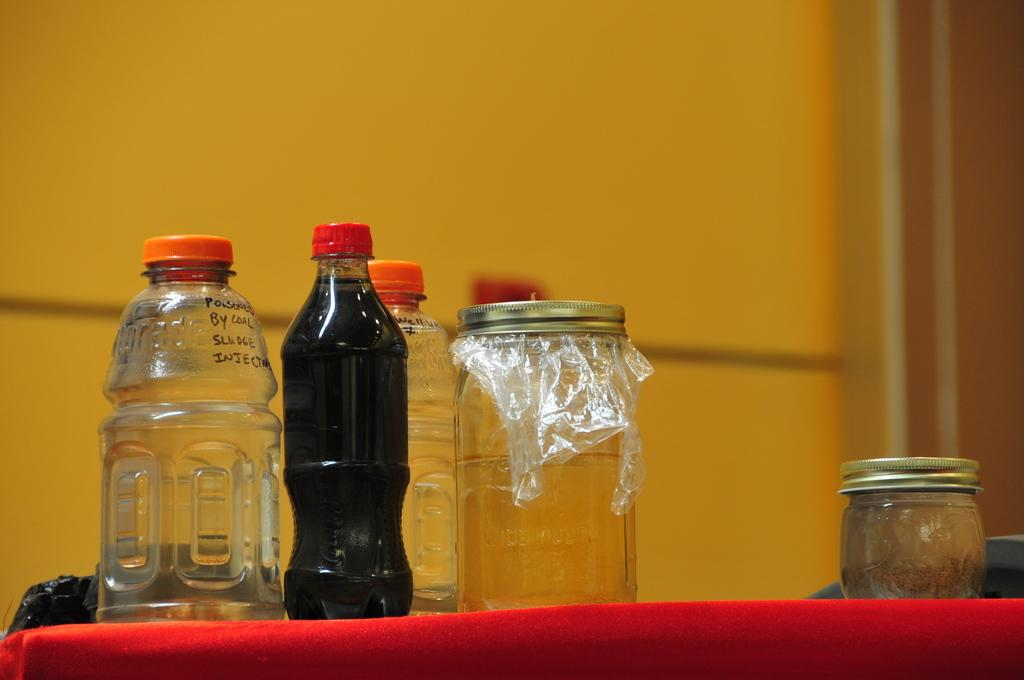How many bottles are visible in the image? There are three bottles in the image. What other containers can be seen in the image? There are two jars in the image. What color is the cloth in the image? The cloth in the image is red. What type of hospital is depicted in the image? There is no hospital present in the image; it only contains bottles, jars, and a red cloth. 